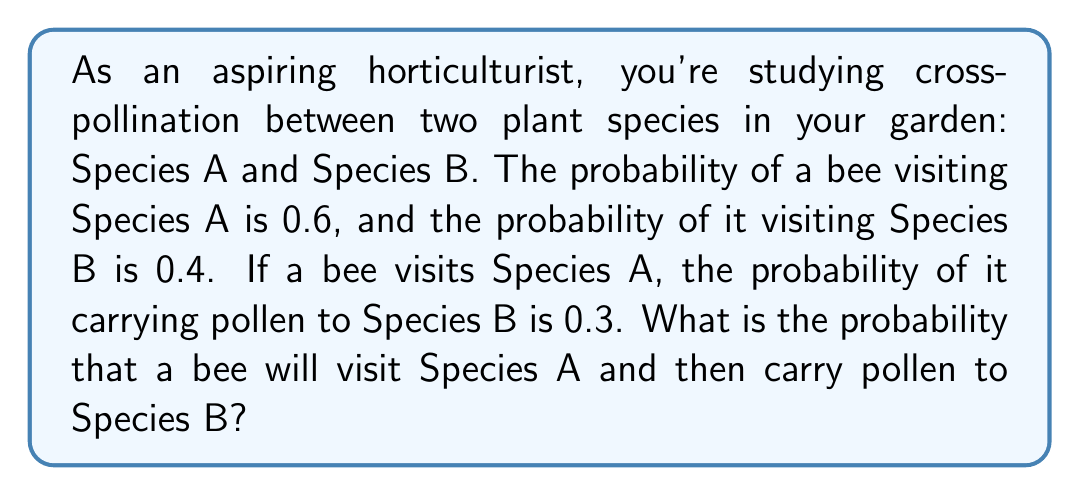Teach me how to tackle this problem. To solve this problem, we'll use the concept of conditional probability. Let's break it down step-by-step:

1. Define events:
   A: Bee visits Species A
   B: Bee carries pollen to Species B

2. Given probabilities:
   P(A) = 0.6 (probability of bee visiting Species A)
   P(B|A) = 0.3 (probability of bee carrying pollen to Species B, given it visited Species A)

3. We need to find P(A and B), which is the probability of both events occurring.

4. The formula for conditional probability is:
   $$P(B|A) = \frac{P(A \text{ and } B)}{P(A)}$$

5. Rearranging this formula, we get:
   $$P(A \text{ and } B) = P(B|A) \cdot P(A)$$

6. Now, let's substitute the values:
   $$P(A \text{ and } B) = 0.3 \cdot 0.6$$

7. Calculate the final probability:
   $$P(A \text{ and } B) = 0.18$$

Therefore, the probability that a bee will visit Species A and then carry pollen to Species B is 0.18 or 18%.
Answer: 0.18 